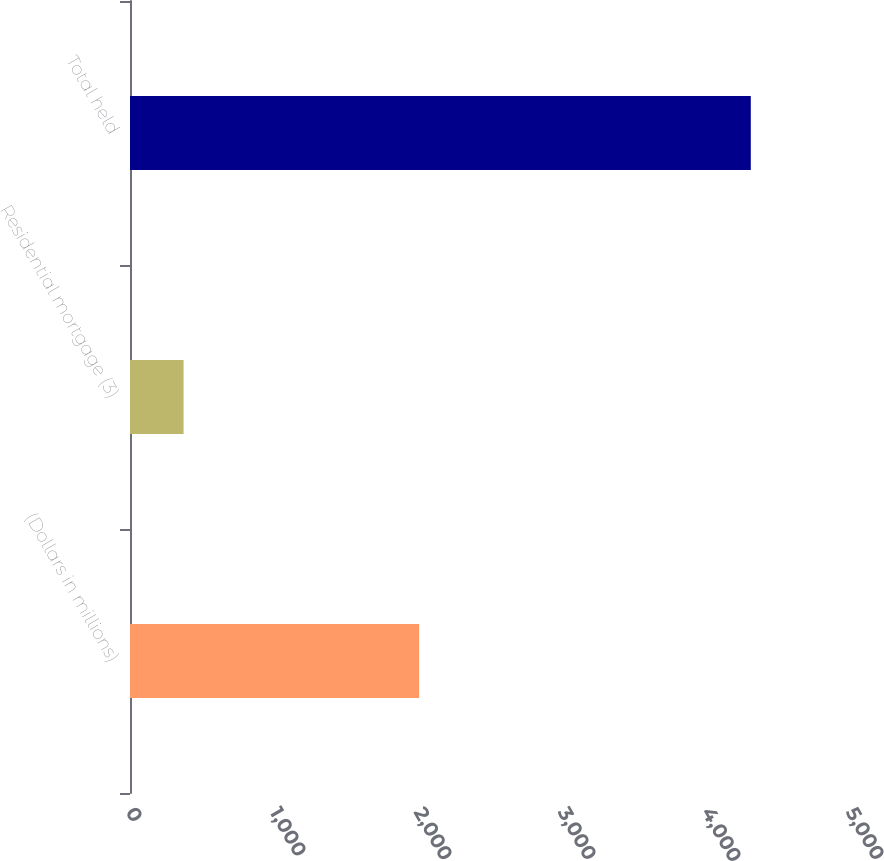Convert chart. <chart><loc_0><loc_0><loc_500><loc_500><bar_chart><fcel>(Dollars in millions)<fcel>Residential mortgage (3)<fcel>Total held<nl><fcel>2008<fcel>372<fcel>4311<nl></chart> 